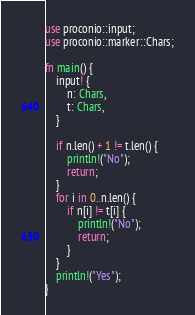Convert code to text. <code><loc_0><loc_0><loc_500><loc_500><_Rust_>use proconio::input;
use proconio::marker::Chars;

fn main() {
    input! {
        n: Chars,
        t: Chars,
    }

    if n.len() + 1 != t.len() {
        println!("No");
        return;
    }
    for i in 0..n.len() {
        if n[i] != t[i] {
            println!("No");
            return;
        }
    }
    println!("Yes");
}</code> 